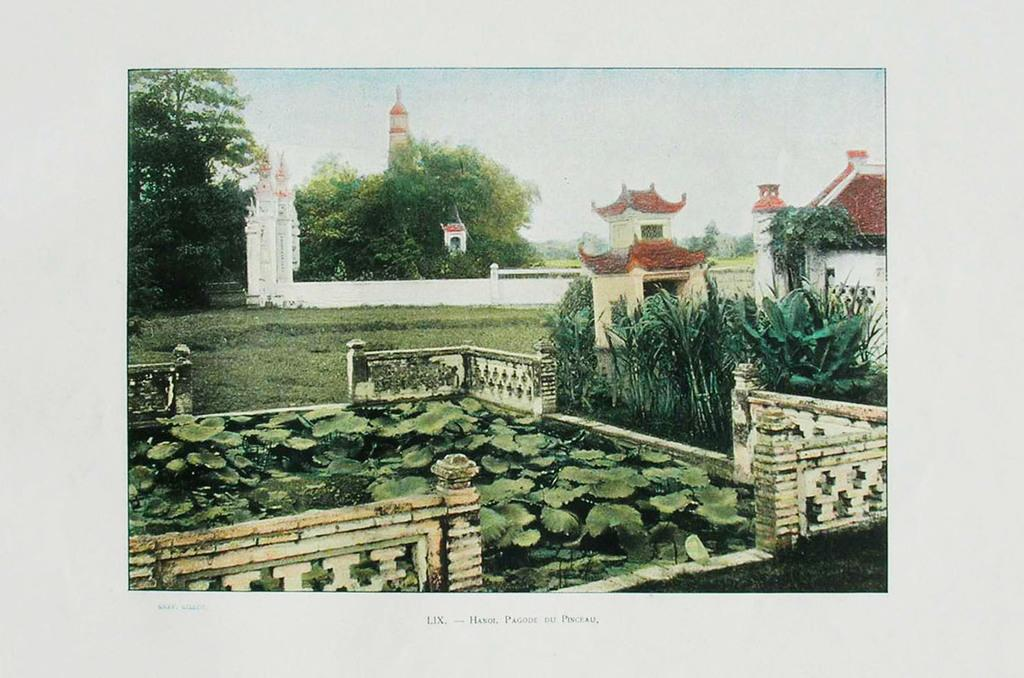What type of vegetation can be seen in the image? There are plants and grass in the image. What architectural feature is present in the image? There is a fence in the image. What type of structure is visible in the image? There is a house in the image. What other man-made structure can be seen in the image? There is a wall in the image. What can be seen in the background of the image? There are trees and the sky visible in the background of the image. Can you hear someone coughing in the image? There is no auditory information provided in the image, so it is not possible to determine if someone is coughing. What type of marble is present in the image? There is no marble present in the image. 